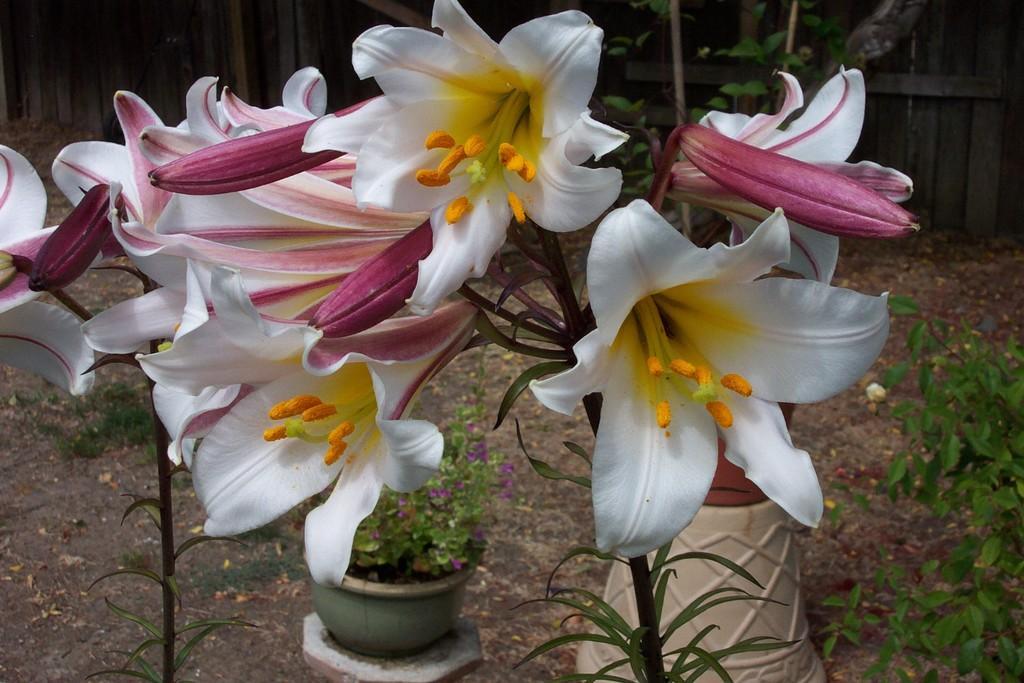Describe this image in one or two sentences. In this image, we can see so many flowers with stems and leaves. Background we can see pots, plants, grass and wall. 